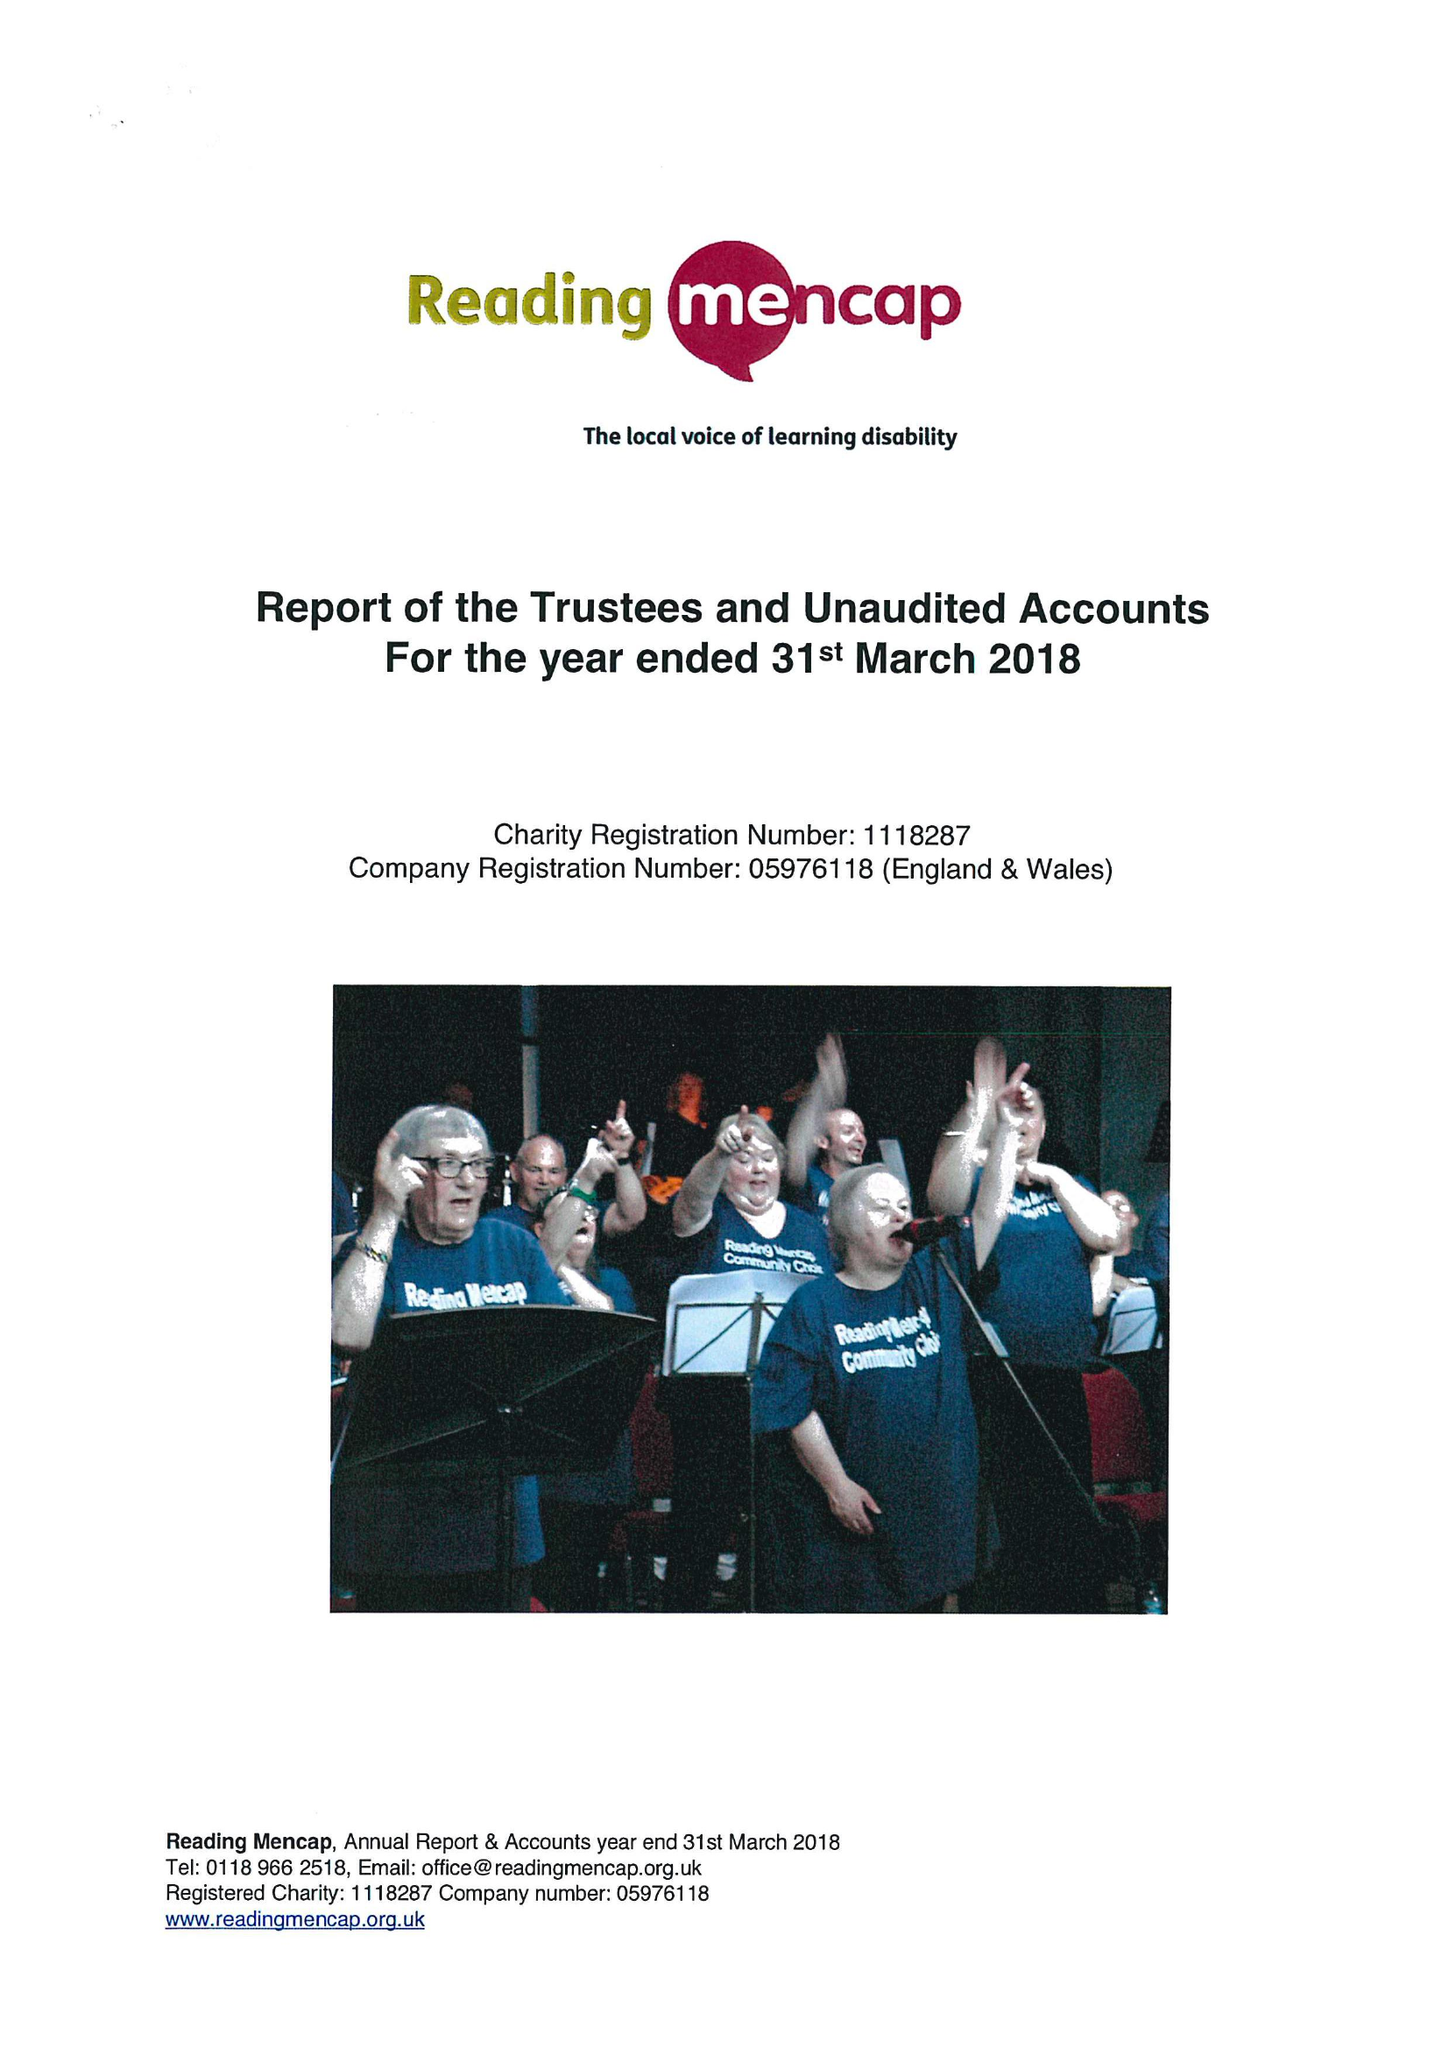What is the value for the address__postcode?
Answer the question using a single word or phrase. RG1 5PE 